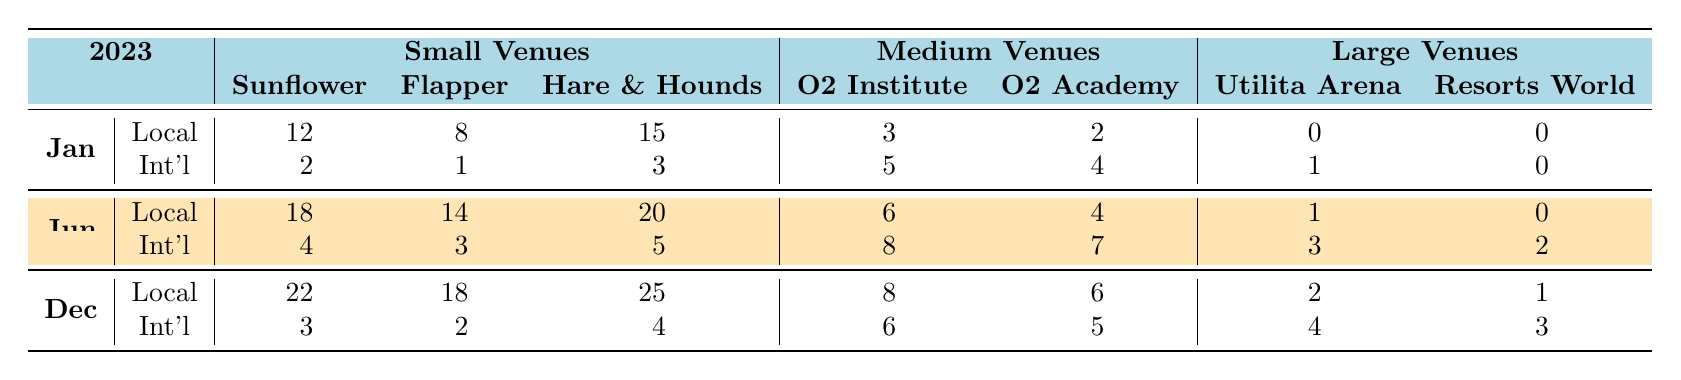What is the total number of local acts performing in small venues in January? To find the total number of local acts in small venues for January, I sum the values for each venue: The Sunflower Lounge (12) + The Flapper (8) + Hare & Hounds (15) = 35.
Answer: 35 How many international acts performed at The Flapper in June? In June, the number of international acts at The Flapper is directly found in the table, where it states there were 3 international acts.
Answer: 3 What is the difference in the number of local acts performing at the Hare & Hounds between June and December? The number of local acts at the Hare & Hounds is 20 in June and 25 in December. The difference is calculated as 25 - 20 = 5.
Answer: 5 Which has more total performances in December: local acts or international acts? For December, local acts total: 22 + 18 + 25 + 8 + 6 + 2 + 1 = 82 and international acts total: 3 + 2 + 4 + 6 + 5 + 4 + 3 = 27. Comparing 82 and 27 shows that local acts have more.
Answer: Local acts What is the average number of performances by local acts across all venue types in June? For local acts in June, sum the performances: 18 + 14 + 20 + 6 + 4 + 1 + 0 = 63. There are 7 entries, so the average is 63 / 7 = 9. The average number of performances is 9.
Answer: 9 Did the number of international acts in large venues increase or decrease from January to June? In January, international acts in large venues totaled 1 (Utilita Arena) + 0 (Resorts World Arena) = 1. In June, they totaled 3 (Utilita Arena) + 2 (Resorts World Arena) = 5. Since 5 is greater than 1, it shows an increase.
Answer: Increase What venue had the highest number of local acts in small venues in December? In December's small venues, The Sunflower Lounge had 22 local acts, which is the highest when compared to The Flapper (18) and Hare & Hounds (25). The highest is confirmed as 25.
Answer: Hare & Hounds How many more performances did local acts have than international acts in small venues for each month combined? For January, local acts had 35 and international acts had 6 (2 + 1 + 3); for June, local acts had 52 and international acts had 19. In December, the local acts had 65 and international acts had 14. Summing them gives local acts 152 and international acts 39, leading to a difference of 152 - 39 = 113.
Answer: 113 Which month had the highest total number of international acts in medium venues? Looking at the medium venues, January had 9 (5 + 4), June had 15 (8 + 7), and December had 11 (6 + 5). Comparing these, June has the highest total of 15.
Answer: June What is the total number of performances in all large venues for December? For December's large venues, Utilita Arena had 2 and Resorts World Arena had 1, with a total for large venues being 2 + 1 = 3.
Answer: 3 